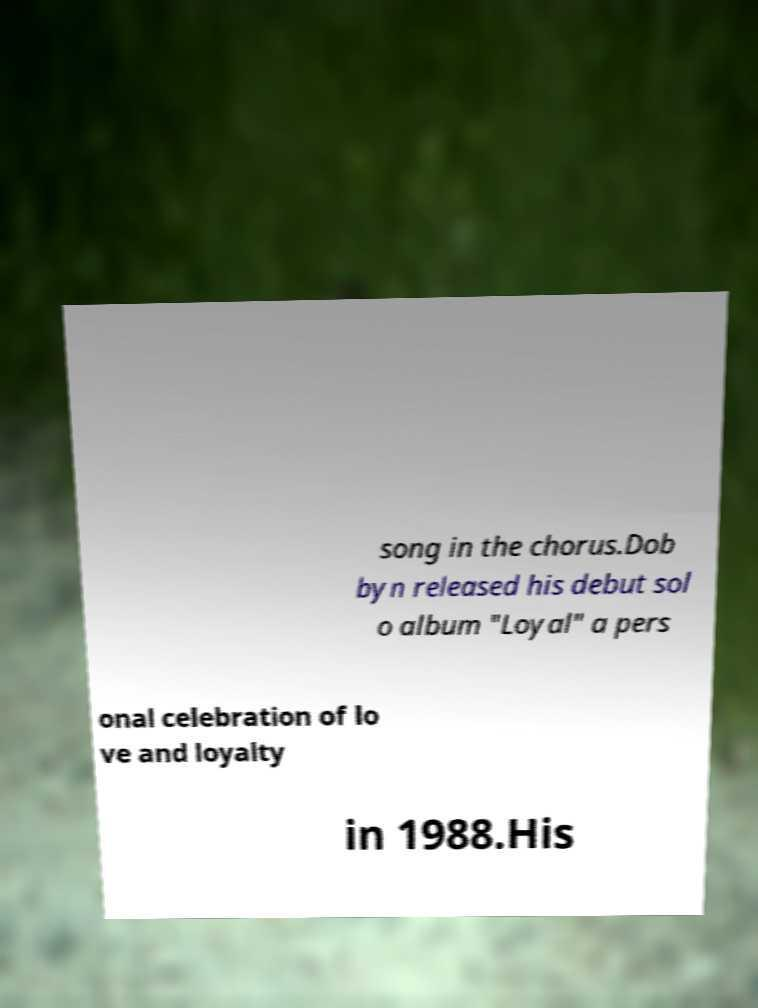There's text embedded in this image that I need extracted. Can you transcribe it verbatim? song in the chorus.Dob byn released his debut sol o album "Loyal" a pers onal celebration of lo ve and loyalty in 1988.His 